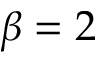<formula> <loc_0><loc_0><loc_500><loc_500>\beta = 2</formula> 